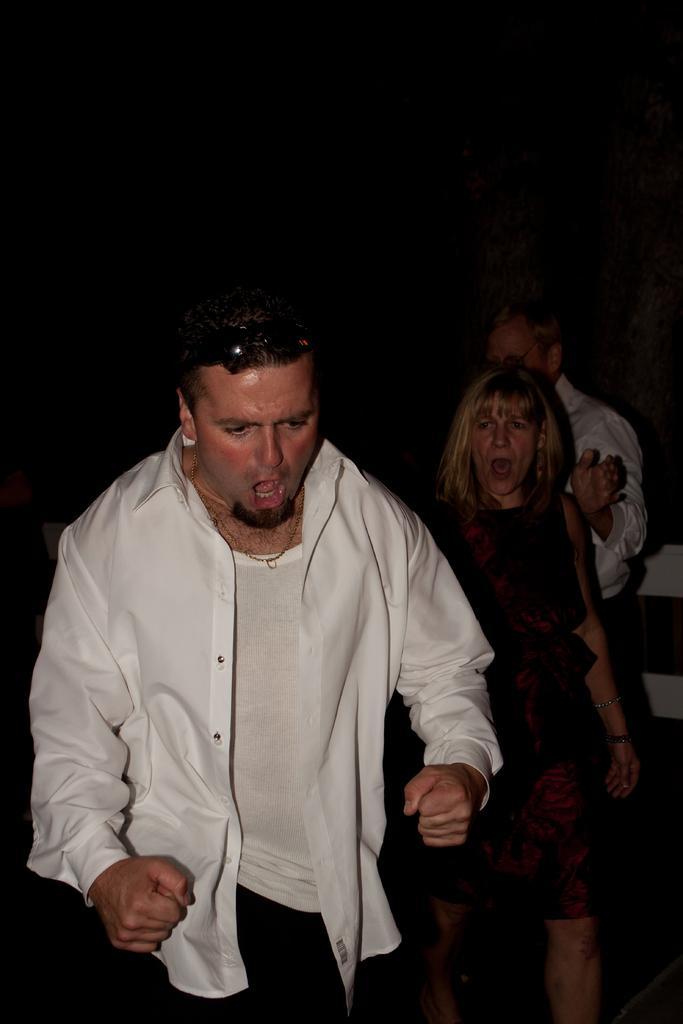In one or two sentences, can you explain what this image depicts? Background portion of the picture is completely dark. In this picture we can see the people. We can see a man and a woman, it seems like they both are screaming. 